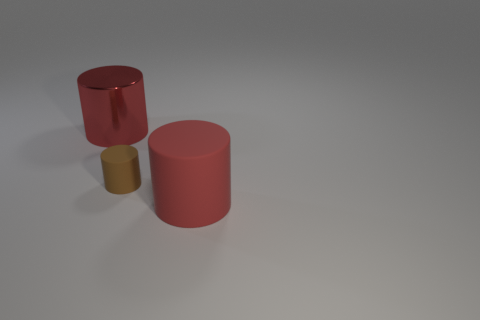There is a large cylinder that is behind the big matte cylinder; is its color the same as the big matte cylinder?
Make the answer very short. Yes. What number of red cylinders are right of the thing on the right side of the small object?
Provide a short and direct response. 0. Do the metallic cylinder and the red rubber object have the same size?
Ensure brevity in your answer.  Yes. What number of tiny brown cylinders have the same material as the small object?
Make the answer very short. 0. There is a brown rubber object that is the same shape as the metal thing; what is its size?
Give a very brief answer. Small. There is a large red object that is on the right side of the metallic cylinder; is its shape the same as the tiny object?
Give a very brief answer. Yes. There is a big red object that is behind the large red cylinder that is to the right of the large red metallic thing; what shape is it?
Your answer should be compact. Cylinder. Are there any other things that have the same shape as the big metal thing?
Offer a very short reply. Yes. There is another metal thing that is the same shape as the small brown thing; what color is it?
Your answer should be very brief. Red. Do the tiny rubber thing and the object behind the small brown rubber object have the same color?
Provide a succinct answer. No. 